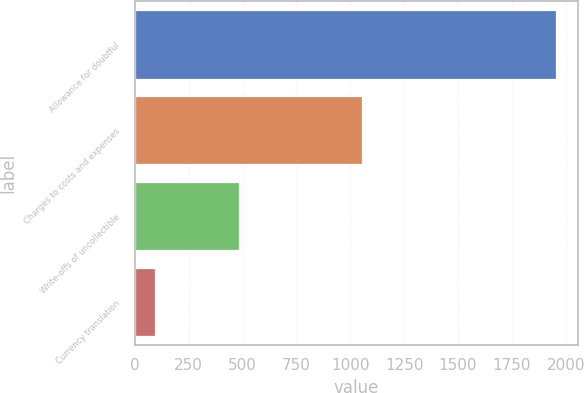Convert chart. <chart><loc_0><loc_0><loc_500><loc_500><bar_chart><fcel>Allowance for doubtful<fcel>Charges to costs and expenses<fcel>Write-offs of uncollectible<fcel>Currency translation<nl><fcel>1957<fcel>1056<fcel>485<fcel>92<nl></chart> 